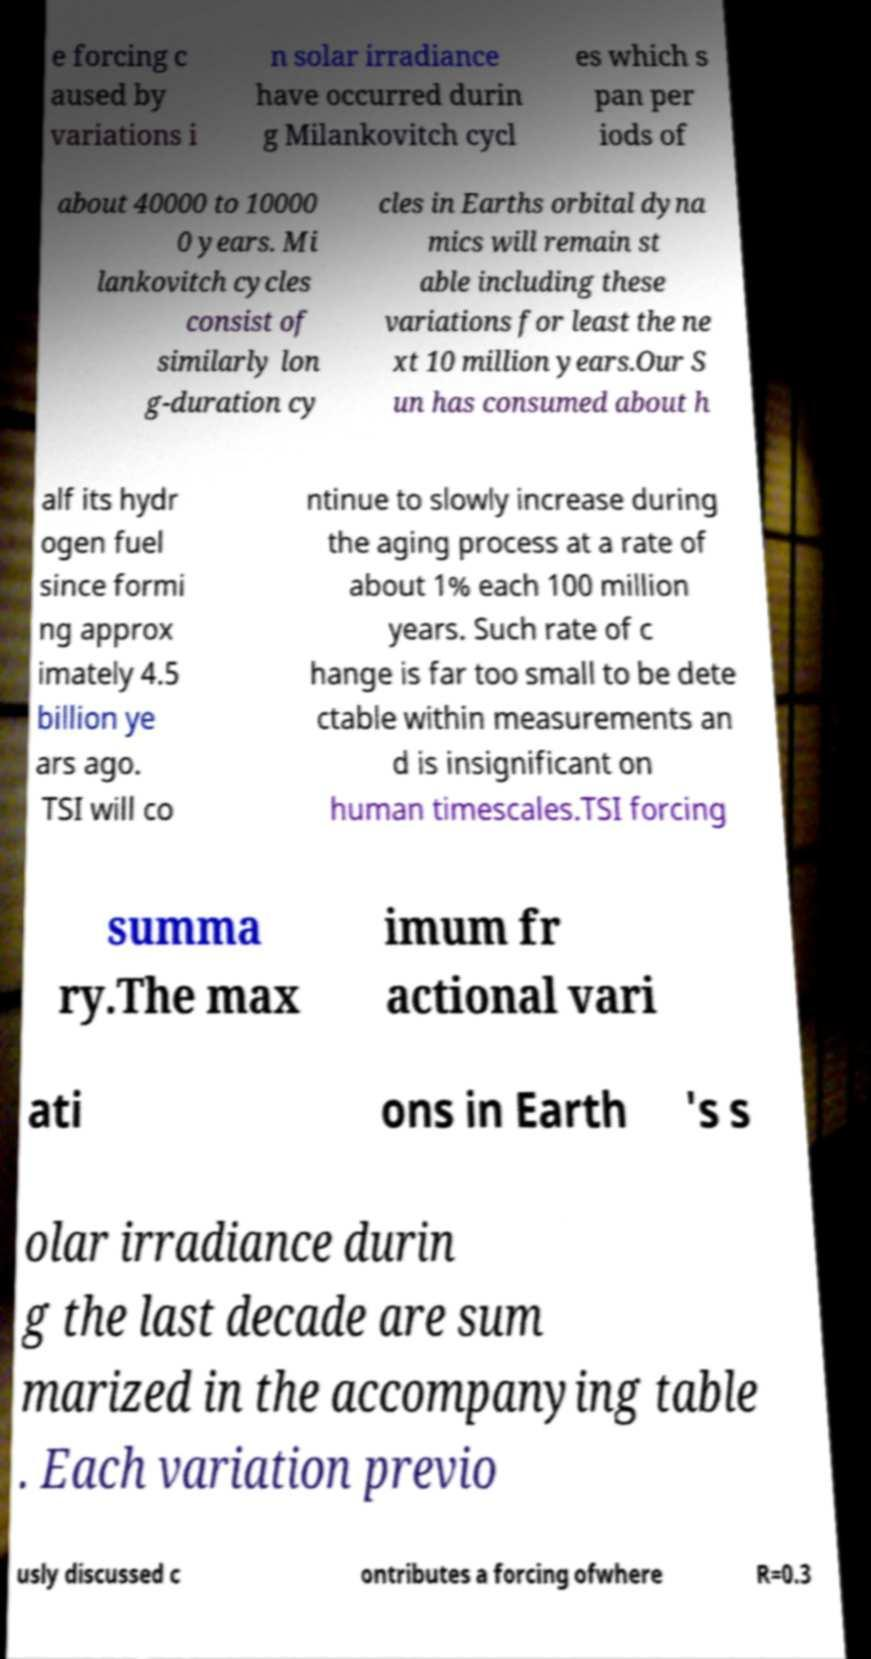I need the written content from this picture converted into text. Can you do that? e forcing c aused by variations i n solar irradiance have occurred durin g Milankovitch cycl es which s pan per iods of about 40000 to 10000 0 years. Mi lankovitch cycles consist of similarly lon g-duration cy cles in Earths orbital dyna mics will remain st able including these variations for least the ne xt 10 million years.Our S un has consumed about h alf its hydr ogen fuel since formi ng approx imately 4.5 billion ye ars ago. TSI will co ntinue to slowly increase during the aging process at a rate of about 1% each 100 million years. Such rate of c hange is far too small to be dete ctable within measurements an d is insignificant on human timescales.TSI forcing summa ry.The max imum fr actional vari ati ons in Earth 's s olar irradiance durin g the last decade are sum marized in the accompanying table . Each variation previo usly discussed c ontributes a forcing ofwhere R=0.3 